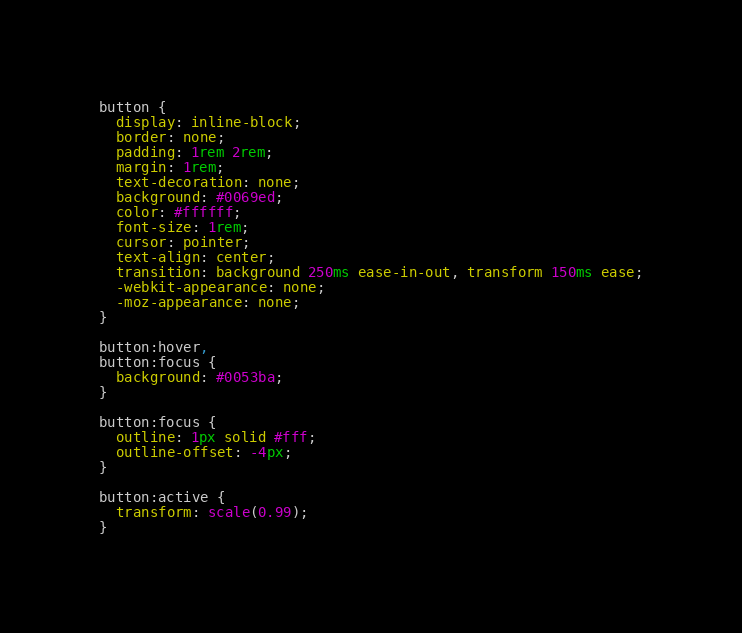Convert code to text. <code><loc_0><loc_0><loc_500><loc_500><_CSS_>button {
  display: inline-block;
  border: none;
  padding: 1rem 2rem;
  margin: 1rem;
  text-decoration: none;
  background: #0069ed;
  color: #ffffff;
  font-size: 1rem;
  cursor: pointer;
  text-align: center;
  transition: background 250ms ease-in-out, transform 150ms ease;
  -webkit-appearance: none;
  -moz-appearance: none;
}

button:hover,
button:focus {
  background: #0053ba;
}

button:focus {
  outline: 1px solid #fff;
  outline-offset: -4px;
}

button:active {
  transform: scale(0.99);
}
</code> 